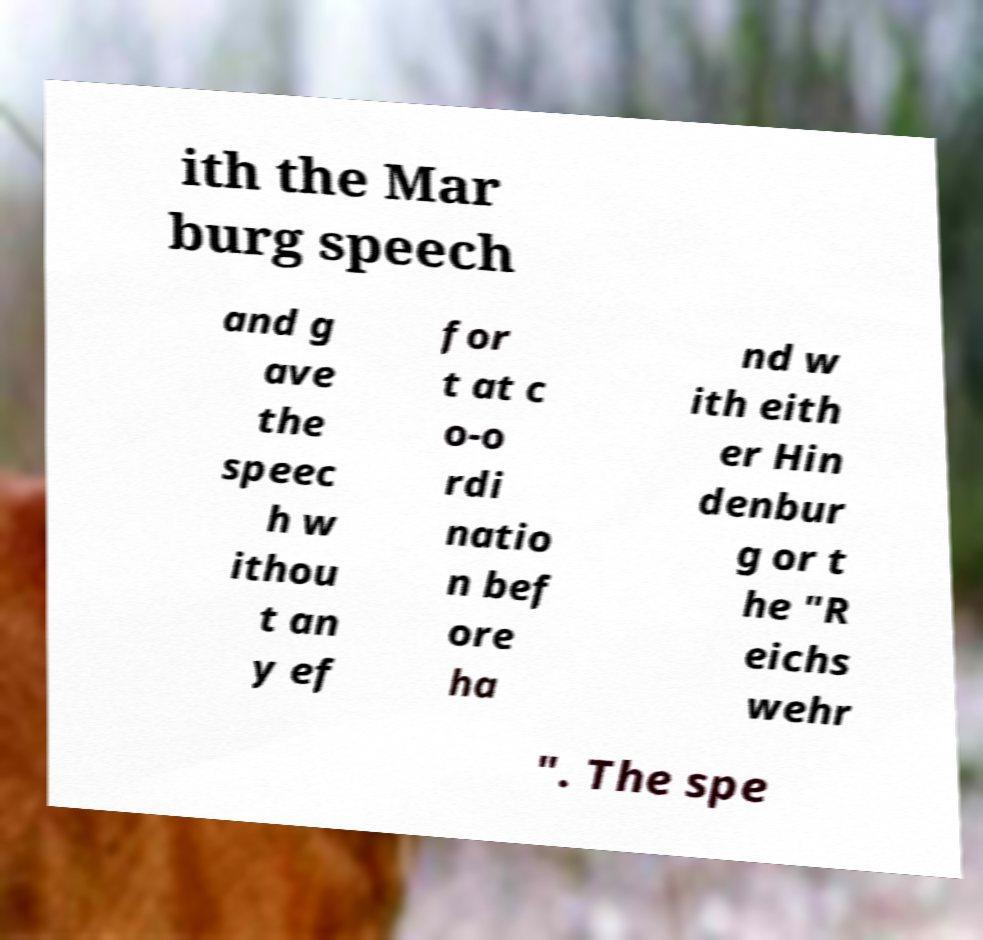Can you read and provide the text displayed in the image?This photo seems to have some interesting text. Can you extract and type it out for me? ith the Mar burg speech and g ave the speec h w ithou t an y ef for t at c o-o rdi natio n bef ore ha nd w ith eith er Hin denbur g or t he "R eichs wehr ". The spe 